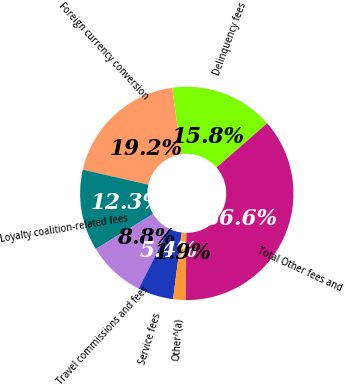<chart> <loc_0><loc_0><loc_500><loc_500><pie_chart><fcel>Delinquency fees<fcel>Foreign currency conversion<fcel>Loyalty coalition-related fees<fcel>Travel commissions and fees<fcel>Service fees<fcel>Other^(a)<fcel>Total Other fees and<nl><fcel>15.77%<fcel>19.24%<fcel>12.3%<fcel>8.84%<fcel>5.37%<fcel>1.9%<fcel>36.58%<nl></chart> 